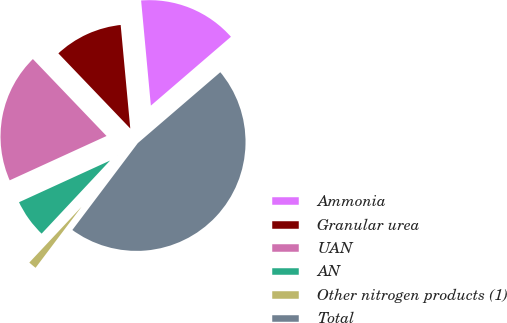Convert chart. <chart><loc_0><loc_0><loc_500><loc_500><pie_chart><fcel>Ammonia<fcel>Granular urea<fcel>UAN<fcel>AN<fcel>Other nitrogen products (1)<fcel>Total<nl><fcel>15.17%<fcel>10.68%<fcel>19.68%<fcel>6.19%<fcel>1.7%<fcel>46.58%<nl></chart> 